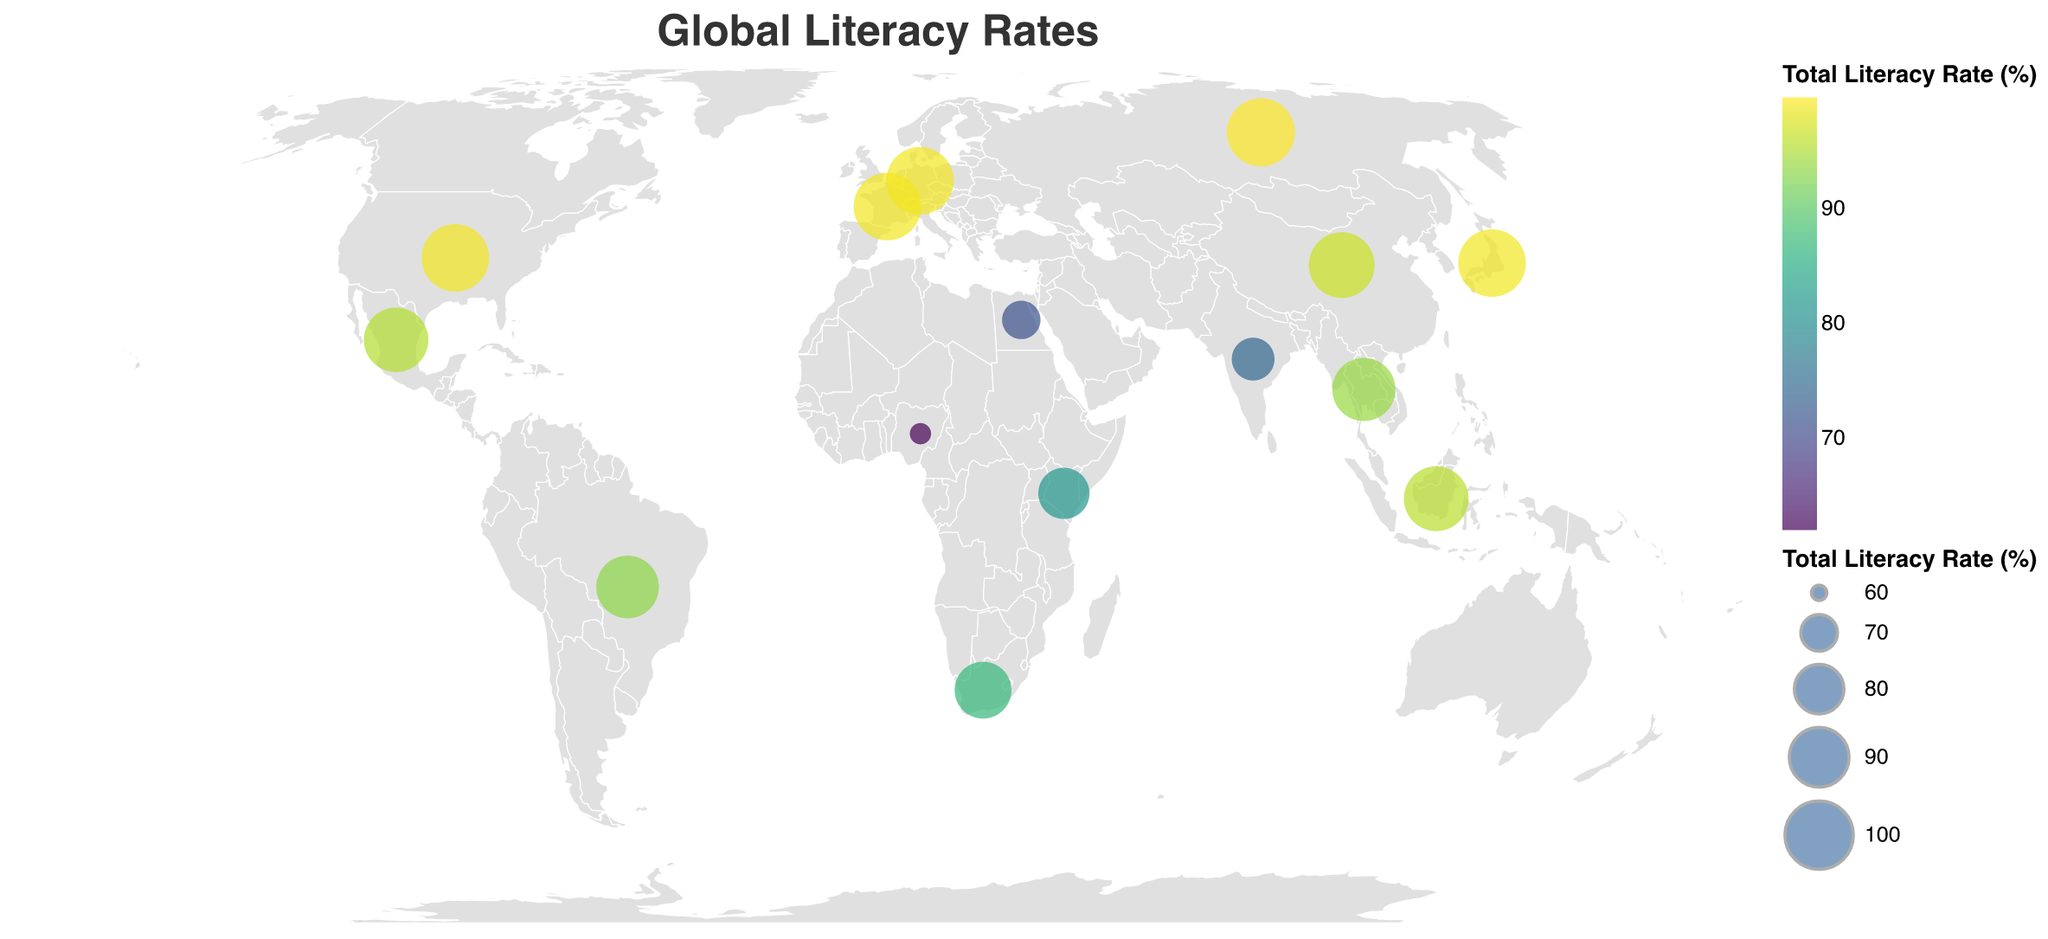What's the highest total literacy rate displayed on the map? To find the highest total literacy rate, look for the largest circles or the darkest colors on the map. Russia has a total literacy rate of 99.7%, which is the highest value present.
Answer: 99.7% Which country in Africa has the lowest literacy rate? To determine which country in Africa has the lowest literacy rate, identify the African countries on the map and compare their values. Nigeria has the lowest literacy rate in Africa with 62.0%.
Answer: Nigeria What is the average total literacy rate of all listed countries? To find the average, sum all the total literacy rates presented and divide by the number of countries. Sum: (99.0 + 74.4 + 96.8 + 93.2 + 62.0 + 99.0 + 99.0 + 71.2 + 95.4 + 87.0 + 95.7 + 99.7 + 81.5 + 99.0 + 93.8) = 1341.7. Average: 1341.7 / 15 ≈ 89.4%
Answer: 89.4% How do the literacy rates of Germany and Egypt compare? Compare the total literacy rates shown on the map for Germany and Egypt. Germany has a literacy rate of 99.0%, while Egypt has a literacy rate of 71.2%. Germany's rate is higher.
Answer: Germany's is higher Which country has a similar literacy rate to Mexico? Look for a country with a total literacy rate close to Mexico's 95.4%. Indonesia, with a literacy rate of 95.7%, has a similar rate to Mexico.
Answer: Indonesia Which country has the second lowest literacy rate? After identifying the country with the lowest literacy rate (Nigeria with 62.0%), find the next lowest. Egypt has the second lowest literacy rate at 71.2%.
Answer: Egypt Between India and China, which country has a higher youth female literacy rate? Compare the values for youth female literacy rates between the two countries. India has 87.3% and China has 99.7%. China has a higher rate.
Answer: China What is the difference in adult female literacy rates between Kenya and South Africa? Subtract the adult female literacy rate of Kenya (78.2%) from South Africa (93.1%). Difference: 93.1% - 78.2% = 14.9%.
Answer: 14.9% How many countries have a total literacy rate of 99.0%? Count the number of countries shown on the map with a total literacy rate of 99.0%. The countries are the United States, Germany, Japan, and France.
Answer: 4 What's the average youth male literacy rate for Brazil and Thailand? Add the youth male literacy rates of Brazil (98.5%) and Thailand (98.1%) and divide by 2. (98.5 + 98.1) / 2 = 98.3%
Answer: 98.3% 